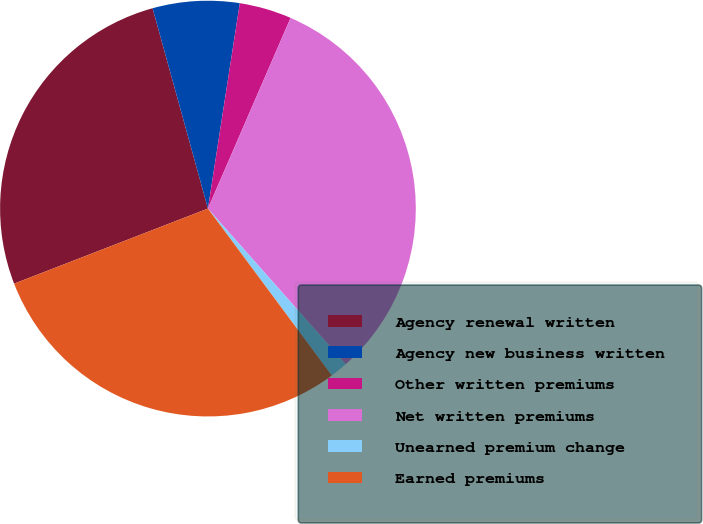Convert chart. <chart><loc_0><loc_0><loc_500><loc_500><pie_chart><fcel>Agency renewal written<fcel>Agency new business written<fcel>Other written premiums<fcel>Net written premiums<fcel>Unearned premium change<fcel>Earned premiums<nl><fcel>26.59%<fcel>6.74%<fcel>4.06%<fcel>31.96%<fcel>1.37%<fcel>29.28%<nl></chart> 